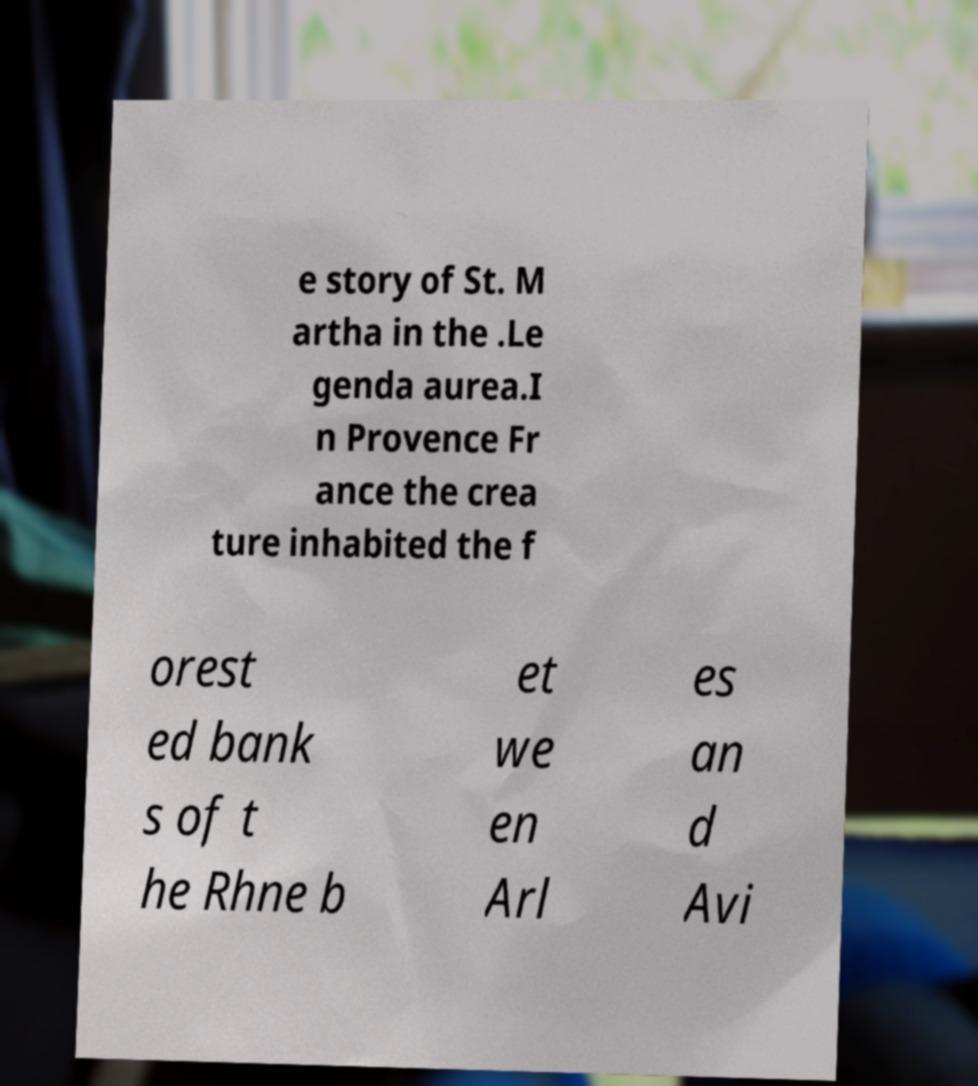Could you extract and type out the text from this image? e story of St. M artha in the .Le genda aurea.I n Provence Fr ance the crea ture inhabited the f orest ed bank s of t he Rhne b et we en Arl es an d Avi 